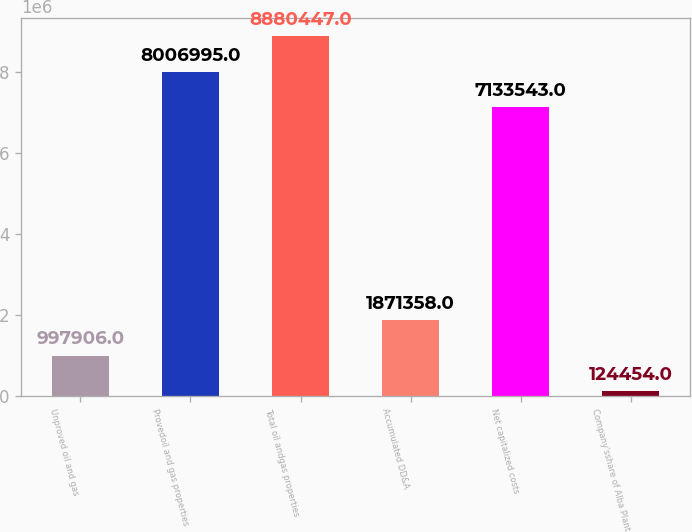<chart> <loc_0><loc_0><loc_500><loc_500><bar_chart><fcel>Unproved oil and gas<fcel>Provedoil and gas properties<fcel>Total oil andgas properties<fcel>Accumulated DD&A<fcel>Net capitalized costs<fcel>Company'sshare of Alba Plant<nl><fcel>997906<fcel>8.007e+06<fcel>8.88045e+06<fcel>1.87136e+06<fcel>7.13354e+06<fcel>124454<nl></chart> 